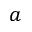Convert formula to latex. <formula><loc_0><loc_0><loc_500><loc_500>a</formula> 